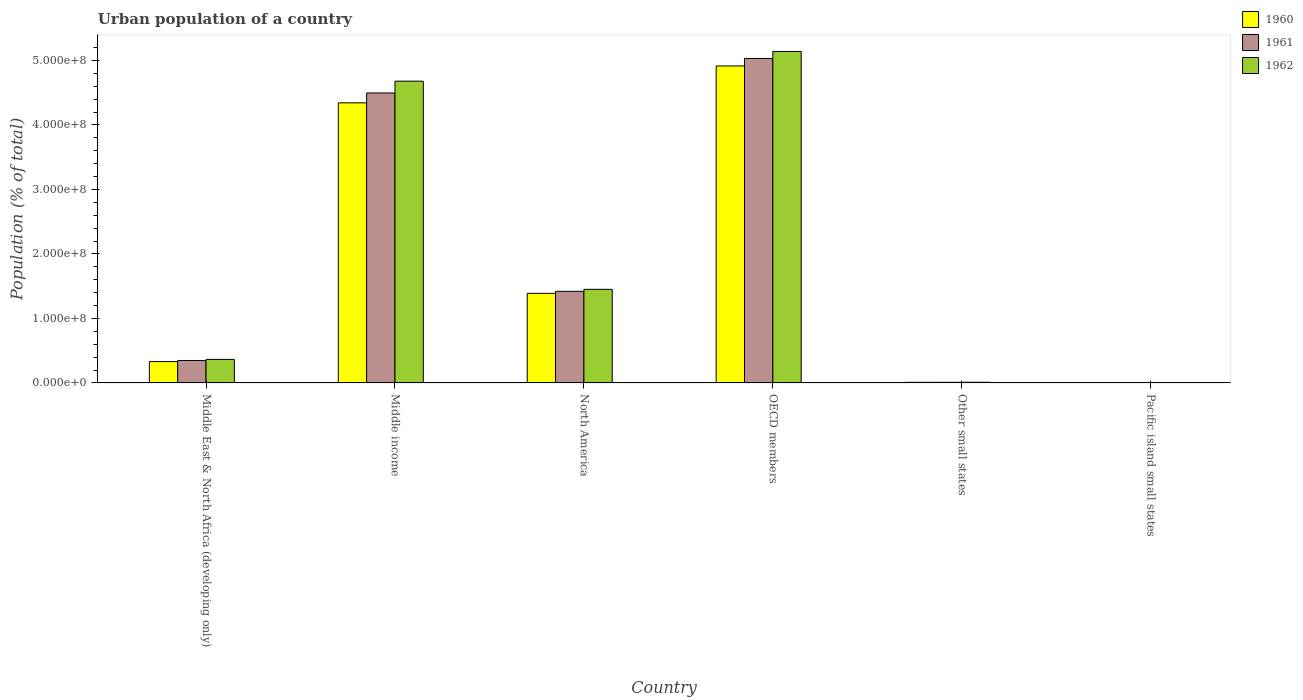How many bars are there on the 1st tick from the right?
Offer a terse response. 3. What is the label of the 1st group of bars from the left?
Your response must be concise. Middle East & North Africa (developing only). What is the urban population in 1961 in OECD members?
Give a very brief answer. 5.03e+08. Across all countries, what is the maximum urban population in 1962?
Offer a very short reply. 5.14e+08. Across all countries, what is the minimum urban population in 1960?
Your response must be concise. 1.90e+05. In which country was the urban population in 1960 maximum?
Provide a short and direct response. OECD members. In which country was the urban population in 1961 minimum?
Your answer should be very brief. Pacific island small states. What is the total urban population in 1961 in the graph?
Make the answer very short. 1.13e+09. What is the difference between the urban population in 1960 in Middle East & North Africa (developing only) and that in Other small states?
Offer a terse response. 3.22e+07. What is the difference between the urban population in 1960 in Middle East & North Africa (developing only) and the urban population in 1962 in Middle income?
Provide a short and direct response. -4.35e+08. What is the average urban population in 1960 per country?
Provide a succinct answer. 1.83e+08. What is the difference between the urban population of/in 1962 and urban population of/in 1961 in Pacific island small states?
Offer a terse response. 1.07e+04. What is the ratio of the urban population in 1960 in North America to that in Pacific island small states?
Offer a very short reply. 731.38. Is the urban population in 1962 in Other small states less than that in Pacific island small states?
Provide a short and direct response. No. What is the difference between the highest and the second highest urban population in 1960?
Offer a very short reply. -5.72e+07. What is the difference between the highest and the lowest urban population in 1962?
Make the answer very short. 5.14e+08. In how many countries, is the urban population in 1960 greater than the average urban population in 1960 taken over all countries?
Provide a succinct answer. 2. Is the sum of the urban population in 1961 in Other small states and Pacific island small states greater than the maximum urban population in 1960 across all countries?
Your answer should be very brief. No. Are all the bars in the graph horizontal?
Your answer should be very brief. No. What is the difference between two consecutive major ticks on the Y-axis?
Give a very brief answer. 1.00e+08. What is the title of the graph?
Keep it short and to the point. Urban population of a country. Does "1999" appear as one of the legend labels in the graph?
Your response must be concise. No. What is the label or title of the Y-axis?
Make the answer very short. Population (% of total). What is the Population (% of total) in 1960 in Middle East & North Africa (developing only)?
Your answer should be very brief. 3.32e+07. What is the Population (% of total) of 1961 in Middle East & North Africa (developing only)?
Provide a short and direct response. 3.48e+07. What is the Population (% of total) of 1962 in Middle East & North Africa (developing only)?
Provide a succinct answer. 3.64e+07. What is the Population (% of total) in 1960 in Middle income?
Your answer should be very brief. 4.34e+08. What is the Population (% of total) in 1961 in Middle income?
Ensure brevity in your answer.  4.50e+08. What is the Population (% of total) of 1962 in Middle income?
Keep it short and to the point. 4.68e+08. What is the Population (% of total) of 1960 in North America?
Your answer should be compact. 1.39e+08. What is the Population (% of total) in 1961 in North America?
Provide a short and direct response. 1.42e+08. What is the Population (% of total) of 1962 in North America?
Your answer should be very brief. 1.45e+08. What is the Population (% of total) in 1960 in OECD members?
Offer a very short reply. 4.92e+08. What is the Population (% of total) of 1961 in OECD members?
Ensure brevity in your answer.  5.03e+08. What is the Population (% of total) in 1962 in OECD members?
Provide a short and direct response. 5.14e+08. What is the Population (% of total) of 1960 in Other small states?
Offer a terse response. 9.45e+05. What is the Population (% of total) of 1961 in Other small states?
Offer a terse response. 9.94e+05. What is the Population (% of total) in 1962 in Other small states?
Your answer should be compact. 1.05e+06. What is the Population (% of total) of 1960 in Pacific island small states?
Make the answer very short. 1.90e+05. What is the Population (% of total) in 1961 in Pacific island small states?
Keep it short and to the point. 2.00e+05. What is the Population (% of total) of 1962 in Pacific island small states?
Offer a terse response. 2.11e+05. Across all countries, what is the maximum Population (% of total) in 1960?
Keep it short and to the point. 4.92e+08. Across all countries, what is the maximum Population (% of total) in 1961?
Make the answer very short. 5.03e+08. Across all countries, what is the maximum Population (% of total) of 1962?
Provide a succinct answer. 5.14e+08. Across all countries, what is the minimum Population (% of total) of 1960?
Your response must be concise. 1.90e+05. Across all countries, what is the minimum Population (% of total) of 1961?
Ensure brevity in your answer.  2.00e+05. Across all countries, what is the minimum Population (% of total) in 1962?
Provide a short and direct response. 2.11e+05. What is the total Population (% of total) of 1960 in the graph?
Your response must be concise. 1.10e+09. What is the total Population (% of total) in 1961 in the graph?
Your answer should be compact. 1.13e+09. What is the total Population (% of total) in 1962 in the graph?
Offer a terse response. 1.16e+09. What is the difference between the Population (% of total) in 1960 in Middle East & North Africa (developing only) and that in Middle income?
Keep it short and to the point. -4.01e+08. What is the difference between the Population (% of total) of 1961 in Middle East & North Africa (developing only) and that in Middle income?
Provide a short and direct response. -4.15e+08. What is the difference between the Population (% of total) of 1962 in Middle East & North Africa (developing only) and that in Middle income?
Give a very brief answer. -4.31e+08. What is the difference between the Population (% of total) in 1960 in Middle East & North Africa (developing only) and that in North America?
Your response must be concise. -1.06e+08. What is the difference between the Population (% of total) of 1961 in Middle East & North Africa (developing only) and that in North America?
Offer a very short reply. -1.07e+08. What is the difference between the Population (% of total) of 1962 in Middle East & North Africa (developing only) and that in North America?
Your answer should be compact. -1.09e+08. What is the difference between the Population (% of total) of 1960 in Middle East & North Africa (developing only) and that in OECD members?
Your answer should be compact. -4.58e+08. What is the difference between the Population (% of total) of 1961 in Middle East & North Africa (developing only) and that in OECD members?
Provide a succinct answer. -4.68e+08. What is the difference between the Population (% of total) in 1962 in Middle East & North Africa (developing only) and that in OECD members?
Provide a short and direct response. -4.78e+08. What is the difference between the Population (% of total) in 1960 in Middle East & North Africa (developing only) and that in Other small states?
Your answer should be compact. 3.22e+07. What is the difference between the Population (% of total) of 1961 in Middle East & North Africa (developing only) and that in Other small states?
Offer a very short reply. 3.38e+07. What is the difference between the Population (% of total) in 1962 in Middle East & North Africa (developing only) and that in Other small states?
Provide a succinct answer. 3.54e+07. What is the difference between the Population (% of total) of 1960 in Middle East & North Africa (developing only) and that in Pacific island small states?
Your answer should be compact. 3.30e+07. What is the difference between the Population (% of total) in 1961 in Middle East & North Africa (developing only) and that in Pacific island small states?
Offer a very short reply. 3.46e+07. What is the difference between the Population (% of total) in 1962 in Middle East & North Africa (developing only) and that in Pacific island small states?
Offer a very short reply. 3.62e+07. What is the difference between the Population (% of total) of 1960 in Middle income and that in North America?
Your answer should be compact. 2.95e+08. What is the difference between the Population (% of total) in 1961 in Middle income and that in North America?
Give a very brief answer. 3.08e+08. What is the difference between the Population (% of total) of 1962 in Middle income and that in North America?
Keep it short and to the point. 3.23e+08. What is the difference between the Population (% of total) of 1960 in Middle income and that in OECD members?
Your answer should be very brief. -5.72e+07. What is the difference between the Population (% of total) in 1961 in Middle income and that in OECD members?
Your response must be concise. -5.35e+07. What is the difference between the Population (% of total) of 1962 in Middle income and that in OECD members?
Your response must be concise. -4.61e+07. What is the difference between the Population (% of total) in 1960 in Middle income and that in Other small states?
Offer a terse response. 4.33e+08. What is the difference between the Population (% of total) of 1961 in Middle income and that in Other small states?
Provide a short and direct response. 4.49e+08. What is the difference between the Population (% of total) of 1962 in Middle income and that in Other small states?
Keep it short and to the point. 4.67e+08. What is the difference between the Population (% of total) of 1960 in Middle income and that in Pacific island small states?
Your answer should be compact. 4.34e+08. What is the difference between the Population (% of total) of 1961 in Middle income and that in Pacific island small states?
Offer a terse response. 4.49e+08. What is the difference between the Population (% of total) of 1962 in Middle income and that in Pacific island small states?
Make the answer very short. 4.68e+08. What is the difference between the Population (% of total) in 1960 in North America and that in OECD members?
Make the answer very short. -3.53e+08. What is the difference between the Population (% of total) in 1961 in North America and that in OECD members?
Offer a very short reply. -3.61e+08. What is the difference between the Population (% of total) in 1962 in North America and that in OECD members?
Offer a terse response. -3.69e+08. What is the difference between the Population (% of total) in 1960 in North America and that in Other small states?
Keep it short and to the point. 1.38e+08. What is the difference between the Population (% of total) of 1961 in North America and that in Other small states?
Offer a terse response. 1.41e+08. What is the difference between the Population (% of total) of 1962 in North America and that in Other small states?
Keep it short and to the point. 1.44e+08. What is the difference between the Population (% of total) in 1960 in North America and that in Pacific island small states?
Keep it short and to the point. 1.39e+08. What is the difference between the Population (% of total) in 1961 in North America and that in Pacific island small states?
Give a very brief answer. 1.42e+08. What is the difference between the Population (% of total) of 1962 in North America and that in Pacific island small states?
Give a very brief answer. 1.45e+08. What is the difference between the Population (% of total) in 1960 in OECD members and that in Other small states?
Provide a short and direct response. 4.91e+08. What is the difference between the Population (% of total) in 1961 in OECD members and that in Other small states?
Offer a terse response. 5.02e+08. What is the difference between the Population (% of total) of 1962 in OECD members and that in Other small states?
Your response must be concise. 5.13e+08. What is the difference between the Population (% of total) of 1960 in OECD members and that in Pacific island small states?
Provide a short and direct response. 4.91e+08. What is the difference between the Population (% of total) in 1961 in OECD members and that in Pacific island small states?
Offer a terse response. 5.03e+08. What is the difference between the Population (% of total) of 1962 in OECD members and that in Pacific island small states?
Give a very brief answer. 5.14e+08. What is the difference between the Population (% of total) of 1960 in Other small states and that in Pacific island small states?
Your answer should be compact. 7.55e+05. What is the difference between the Population (% of total) of 1961 in Other small states and that in Pacific island small states?
Provide a short and direct response. 7.94e+05. What is the difference between the Population (% of total) of 1962 in Other small states and that in Pacific island small states?
Offer a terse response. 8.35e+05. What is the difference between the Population (% of total) in 1960 in Middle East & North Africa (developing only) and the Population (% of total) in 1961 in Middle income?
Offer a very short reply. -4.16e+08. What is the difference between the Population (% of total) in 1960 in Middle East & North Africa (developing only) and the Population (% of total) in 1962 in Middle income?
Offer a terse response. -4.35e+08. What is the difference between the Population (% of total) of 1961 in Middle East & North Africa (developing only) and the Population (% of total) of 1962 in Middle income?
Give a very brief answer. -4.33e+08. What is the difference between the Population (% of total) in 1960 in Middle East & North Africa (developing only) and the Population (% of total) in 1961 in North America?
Provide a short and direct response. -1.09e+08. What is the difference between the Population (% of total) of 1960 in Middle East & North Africa (developing only) and the Population (% of total) of 1962 in North America?
Ensure brevity in your answer.  -1.12e+08. What is the difference between the Population (% of total) of 1961 in Middle East & North Africa (developing only) and the Population (% of total) of 1962 in North America?
Your answer should be compact. -1.10e+08. What is the difference between the Population (% of total) of 1960 in Middle East & North Africa (developing only) and the Population (% of total) of 1961 in OECD members?
Offer a very short reply. -4.70e+08. What is the difference between the Population (% of total) of 1960 in Middle East & North Africa (developing only) and the Population (% of total) of 1962 in OECD members?
Offer a terse response. -4.81e+08. What is the difference between the Population (% of total) in 1961 in Middle East & North Africa (developing only) and the Population (% of total) in 1962 in OECD members?
Your answer should be very brief. -4.79e+08. What is the difference between the Population (% of total) of 1960 in Middle East & North Africa (developing only) and the Population (% of total) of 1961 in Other small states?
Give a very brief answer. 3.22e+07. What is the difference between the Population (% of total) in 1960 in Middle East & North Africa (developing only) and the Population (% of total) in 1962 in Other small states?
Provide a short and direct response. 3.21e+07. What is the difference between the Population (% of total) in 1961 in Middle East & North Africa (developing only) and the Population (% of total) in 1962 in Other small states?
Offer a very short reply. 3.37e+07. What is the difference between the Population (% of total) of 1960 in Middle East & North Africa (developing only) and the Population (% of total) of 1961 in Pacific island small states?
Your answer should be very brief. 3.30e+07. What is the difference between the Population (% of total) in 1960 in Middle East & North Africa (developing only) and the Population (% of total) in 1962 in Pacific island small states?
Your answer should be compact. 3.29e+07. What is the difference between the Population (% of total) in 1961 in Middle East & North Africa (developing only) and the Population (% of total) in 1962 in Pacific island small states?
Provide a succinct answer. 3.46e+07. What is the difference between the Population (% of total) of 1960 in Middle income and the Population (% of total) of 1961 in North America?
Offer a terse response. 2.92e+08. What is the difference between the Population (% of total) of 1960 in Middle income and the Population (% of total) of 1962 in North America?
Give a very brief answer. 2.89e+08. What is the difference between the Population (% of total) in 1961 in Middle income and the Population (% of total) in 1962 in North America?
Your answer should be compact. 3.04e+08. What is the difference between the Population (% of total) of 1960 in Middle income and the Population (% of total) of 1961 in OECD members?
Make the answer very short. -6.88e+07. What is the difference between the Population (% of total) in 1960 in Middle income and the Population (% of total) in 1962 in OECD members?
Offer a terse response. -7.97e+07. What is the difference between the Population (% of total) of 1961 in Middle income and the Population (% of total) of 1962 in OECD members?
Make the answer very short. -6.44e+07. What is the difference between the Population (% of total) of 1960 in Middle income and the Population (% of total) of 1961 in Other small states?
Your answer should be compact. 4.33e+08. What is the difference between the Population (% of total) of 1960 in Middle income and the Population (% of total) of 1962 in Other small states?
Your response must be concise. 4.33e+08. What is the difference between the Population (% of total) in 1961 in Middle income and the Population (% of total) in 1962 in Other small states?
Offer a very short reply. 4.49e+08. What is the difference between the Population (% of total) in 1960 in Middle income and the Population (% of total) in 1961 in Pacific island small states?
Give a very brief answer. 4.34e+08. What is the difference between the Population (% of total) of 1960 in Middle income and the Population (% of total) of 1962 in Pacific island small states?
Your answer should be very brief. 4.34e+08. What is the difference between the Population (% of total) in 1961 in Middle income and the Population (% of total) in 1962 in Pacific island small states?
Your answer should be very brief. 4.49e+08. What is the difference between the Population (% of total) in 1960 in North America and the Population (% of total) in 1961 in OECD members?
Provide a succinct answer. -3.64e+08. What is the difference between the Population (% of total) in 1960 in North America and the Population (% of total) in 1962 in OECD members?
Your answer should be compact. -3.75e+08. What is the difference between the Population (% of total) of 1961 in North America and the Population (% of total) of 1962 in OECD members?
Your answer should be compact. -3.72e+08. What is the difference between the Population (% of total) in 1960 in North America and the Population (% of total) in 1961 in Other small states?
Ensure brevity in your answer.  1.38e+08. What is the difference between the Population (% of total) of 1960 in North America and the Population (% of total) of 1962 in Other small states?
Offer a terse response. 1.38e+08. What is the difference between the Population (% of total) of 1961 in North America and the Population (% of total) of 1962 in Other small states?
Make the answer very short. 1.41e+08. What is the difference between the Population (% of total) in 1960 in North America and the Population (% of total) in 1961 in Pacific island small states?
Offer a very short reply. 1.39e+08. What is the difference between the Population (% of total) of 1960 in North America and the Population (% of total) of 1962 in Pacific island small states?
Your answer should be very brief. 1.39e+08. What is the difference between the Population (% of total) in 1961 in North America and the Population (% of total) in 1962 in Pacific island small states?
Provide a succinct answer. 1.42e+08. What is the difference between the Population (% of total) of 1960 in OECD members and the Population (% of total) of 1961 in Other small states?
Ensure brevity in your answer.  4.91e+08. What is the difference between the Population (% of total) of 1960 in OECD members and the Population (% of total) of 1962 in Other small states?
Provide a short and direct response. 4.90e+08. What is the difference between the Population (% of total) of 1961 in OECD members and the Population (% of total) of 1962 in Other small states?
Offer a very short reply. 5.02e+08. What is the difference between the Population (% of total) of 1960 in OECD members and the Population (% of total) of 1961 in Pacific island small states?
Provide a short and direct response. 4.91e+08. What is the difference between the Population (% of total) in 1960 in OECD members and the Population (% of total) in 1962 in Pacific island small states?
Give a very brief answer. 4.91e+08. What is the difference between the Population (% of total) in 1961 in OECD members and the Population (% of total) in 1962 in Pacific island small states?
Your response must be concise. 5.03e+08. What is the difference between the Population (% of total) in 1960 in Other small states and the Population (% of total) in 1961 in Pacific island small states?
Offer a terse response. 7.45e+05. What is the difference between the Population (% of total) of 1960 in Other small states and the Population (% of total) of 1962 in Pacific island small states?
Your response must be concise. 7.34e+05. What is the difference between the Population (% of total) of 1961 in Other small states and the Population (% of total) of 1962 in Pacific island small states?
Make the answer very short. 7.83e+05. What is the average Population (% of total) in 1960 per country?
Keep it short and to the point. 1.83e+08. What is the average Population (% of total) in 1961 per country?
Ensure brevity in your answer.  1.88e+08. What is the average Population (% of total) in 1962 per country?
Offer a terse response. 1.94e+08. What is the difference between the Population (% of total) in 1960 and Population (% of total) in 1961 in Middle East & North Africa (developing only)?
Give a very brief answer. -1.61e+06. What is the difference between the Population (% of total) of 1960 and Population (% of total) of 1962 in Middle East & North Africa (developing only)?
Give a very brief answer. -3.29e+06. What is the difference between the Population (% of total) in 1961 and Population (% of total) in 1962 in Middle East & North Africa (developing only)?
Provide a short and direct response. -1.68e+06. What is the difference between the Population (% of total) in 1960 and Population (% of total) in 1961 in Middle income?
Provide a short and direct response. -1.53e+07. What is the difference between the Population (% of total) in 1960 and Population (% of total) in 1962 in Middle income?
Offer a terse response. -3.36e+07. What is the difference between the Population (% of total) in 1961 and Population (% of total) in 1962 in Middle income?
Make the answer very short. -1.83e+07. What is the difference between the Population (% of total) of 1960 and Population (% of total) of 1961 in North America?
Offer a terse response. -3.18e+06. What is the difference between the Population (% of total) of 1960 and Population (% of total) of 1962 in North America?
Provide a succinct answer. -6.28e+06. What is the difference between the Population (% of total) in 1961 and Population (% of total) in 1962 in North America?
Your answer should be very brief. -3.11e+06. What is the difference between the Population (% of total) of 1960 and Population (% of total) of 1961 in OECD members?
Your answer should be very brief. -1.16e+07. What is the difference between the Population (% of total) in 1960 and Population (% of total) in 1962 in OECD members?
Offer a terse response. -2.25e+07. What is the difference between the Population (% of total) of 1961 and Population (% of total) of 1962 in OECD members?
Provide a succinct answer. -1.09e+07. What is the difference between the Population (% of total) of 1960 and Population (% of total) of 1961 in Other small states?
Ensure brevity in your answer.  -4.89e+04. What is the difference between the Population (% of total) in 1960 and Population (% of total) in 1962 in Other small states?
Provide a short and direct response. -1.01e+05. What is the difference between the Population (% of total) of 1961 and Population (% of total) of 1962 in Other small states?
Give a very brief answer. -5.20e+04. What is the difference between the Population (% of total) in 1960 and Population (% of total) in 1961 in Pacific island small states?
Your answer should be compact. -1.00e+04. What is the difference between the Population (% of total) of 1960 and Population (% of total) of 1962 in Pacific island small states?
Keep it short and to the point. -2.08e+04. What is the difference between the Population (% of total) of 1961 and Population (% of total) of 1962 in Pacific island small states?
Your answer should be very brief. -1.07e+04. What is the ratio of the Population (% of total) in 1960 in Middle East & North Africa (developing only) to that in Middle income?
Provide a succinct answer. 0.08. What is the ratio of the Population (% of total) of 1961 in Middle East & North Africa (developing only) to that in Middle income?
Make the answer very short. 0.08. What is the ratio of the Population (% of total) of 1962 in Middle East & North Africa (developing only) to that in Middle income?
Provide a short and direct response. 0.08. What is the ratio of the Population (% of total) in 1960 in Middle East & North Africa (developing only) to that in North America?
Ensure brevity in your answer.  0.24. What is the ratio of the Population (% of total) of 1961 in Middle East & North Africa (developing only) to that in North America?
Give a very brief answer. 0.24. What is the ratio of the Population (% of total) in 1962 in Middle East & North Africa (developing only) to that in North America?
Make the answer very short. 0.25. What is the ratio of the Population (% of total) of 1960 in Middle East & North Africa (developing only) to that in OECD members?
Ensure brevity in your answer.  0.07. What is the ratio of the Population (% of total) in 1961 in Middle East & North Africa (developing only) to that in OECD members?
Ensure brevity in your answer.  0.07. What is the ratio of the Population (% of total) of 1962 in Middle East & North Africa (developing only) to that in OECD members?
Provide a short and direct response. 0.07. What is the ratio of the Population (% of total) in 1960 in Middle East & North Africa (developing only) to that in Other small states?
Make the answer very short. 35.08. What is the ratio of the Population (% of total) of 1961 in Middle East & North Africa (developing only) to that in Other small states?
Your answer should be very brief. 34.98. What is the ratio of the Population (% of total) in 1962 in Middle East & North Africa (developing only) to that in Other small states?
Offer a very short reply. 34.84. What is the ratio of the Population (% of total) in 1960 in Middle East & North Africa (developing only) to that in Pacific island small states?
Provide a succinct answer. 174.6. What is the ratio of the Population (% of total) in 1961 in Middle East & North Africa (developing only) to that in Pacific island small states?
Give a very brief answer. 173.89. What is the ratio of the Population (% of total) in 1962 in Middle East & North Africa (developing only) to that in Pacific island small states?
Your answer should be compact. 173.01. What is the ratio of the Population (% of total) of 1960 in Middle income to that in North America?
Ensure brevity in your answer.  3.13. What is the ratio of the Population (% of total) in 1961 in Middle income to that in North America?
Offer a terse response. 3.17. What is the ratio of the Population (% of total) in 1962 in Middle income to that in North America?
Give a very brief answer. 3.22. What is the ratio of the Population (% of total) in 1960 in Middle income to that in OECD members?
Keep it short and to the point. 0.88. What is the ratio of the Population (% of total) of 1961 in Middle income to that in OECD members?
Ensure brevity in your answer.  0.89. What is the ratio of the Population (% of total) in 1962 in Middle income to that in OECD members?
Make the answer very short. 0.91. What is the ratio of the Population (% of total) in 1960 in Middle income to that in Other small states?
Your answer should be very brief. 459.58. What is the ratio of the Population (% of total) in 1961 in Middle income to that in Other small states?
Provide a short and direct response. 452.36. What is the ratio of the Population (% of total) of 1962 in Middle income to that in Other small states?
Ensure brevity in your answer.  447.35. What is the ratio of the Population (% of total) of 1960 in Middle income to that in Pacific island small states?
Offer a very short reply. 2287.12. What is the ratio of the Population (% of total) in 1961 in Middle income to that in Pacific island small states?
Provide a succinct answer. 2248.91. What is the ratio of the Population (% of total) in 1962 in Middle income to that in Pacific island small states?
Your answer should be compact. 2221.25. What is the ratio of the Population (% of total) in 1960 in North America to that in OECD members?
Your response must be concise. 0.28. What is the ratio of the Population (% of total) in 1961 in North America to that in OECD members?
Offer a very short reply. 0.28. What is the ratio of the Population (% of total) in 1962 in North America to that in OECD members?
Offer a very short reply. 0.28. What is the ratio of the Population (% of total) in 1960 in North America to that in Other small states?
Offer a very short reply. 146.97. What is the ratio of the Population (% of total) in 1961 in North America to that in Other small states?
Your answer should be compact. 142.93. What is the ratio of the Population (% of total) of 1962 in North America to that in Other small states?
Make the answer very short. 138.79. What is the ratio of the Population (% of total) in 1960 in North America to that in Pacific island small states?
Make the answer very short. 731.38. What is the ratio of the Population (% of total) of 1961 in North America to that in Pacific island small states?
Provide a short and direct response. 710.57. What is the ratio of the Population (% of total) of 1962 in North America to that in Pacific island small states?
Give a very brief answer. 689.13. What is the ratio of the Population (% of total) of 1960 in OECD members to that in Other small states?
Ensure brevity in your answer.  520.14. What is the ratio of the Population (% of total) in 1961 in OECD members to that in Other small states?
Provide a short and direct response. 506.22. What is the ratio of the Population (% of total) of 1962 in OECD members to that in Other small states?
Provide a short and direct response. 491.42. What is the ratio of the Population (% of total) in 1960 in OECD members to that in Pacific island small states?
Your response must be concise. 2588.5. What is the ratio of the Population (% of total) of 1961 in OECD members to that in Pacific island small states?
Provide a succinct answer. 2516.66. What is the ratio of the Population (% of total) of 1962 in OECD members to that in Pacific island small states?
Keep it short and to the point. 2440.07. What is the ratio of the Population (% of total) in 1960 in Other small states to that in Pacific island small states?
Make the answer very short. 4.98. What is the ratio of the Population (% of total) of 1961 in Other small states to that in Pacific island small states?
Your answer should be compact. 4.97. What is the ratio of the Population (% of total) of 1962 in Other small states to that in Pacific island small states?
Provide a succinct answer. 4.97. What is the difference between the highest and the second highest Population (% of total) in 1960?
Ensure brevity in your answer.  5.72e+07. What is the difference between the highest and the second highest Population (% of total) of 1961?
Your answer should be very brief. 5.35e+07. What is the difference between the highest and the second highest Population (% of total) of 1962?
Make the answer very short. 4.61e+07. What is the difference between the highest and the lowest Population (% of total) in 1960?
Give a very brief answer. 4.91e+08. What is the difference between the highest and the lowest Population (% of total) of 1961?
Provide a succinct answer. 5.03e+08. What is the difference between the highest and the lowest Population (% of total) in 1962?
Give a very brief answer. 5.14e+08. 